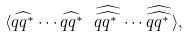Convert formula to latex. <formula><loc_0><loc_0><loc_500><loc_500>\langle \widehat { q q ^ { * } } \cdots \widehat { q q ^ { * } } \ \widehat { \widehat { q q ^ { * } \, } } \cdots \widehat { \widehat { q q ^ { * } \, } } \rangle ,</formula> 